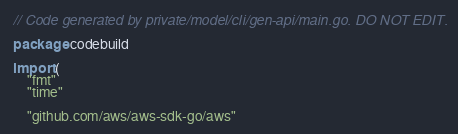<code> <loc_0><loc_0><loc_500><loc_500><_Go_>// Code generated by private/model/cli/gen-api/main.go. DO NOT EDIT.

package codebuild

import (
	"fmt"
	"time"

	"github.com/aws/aws-sdk-go/aws"</code> 